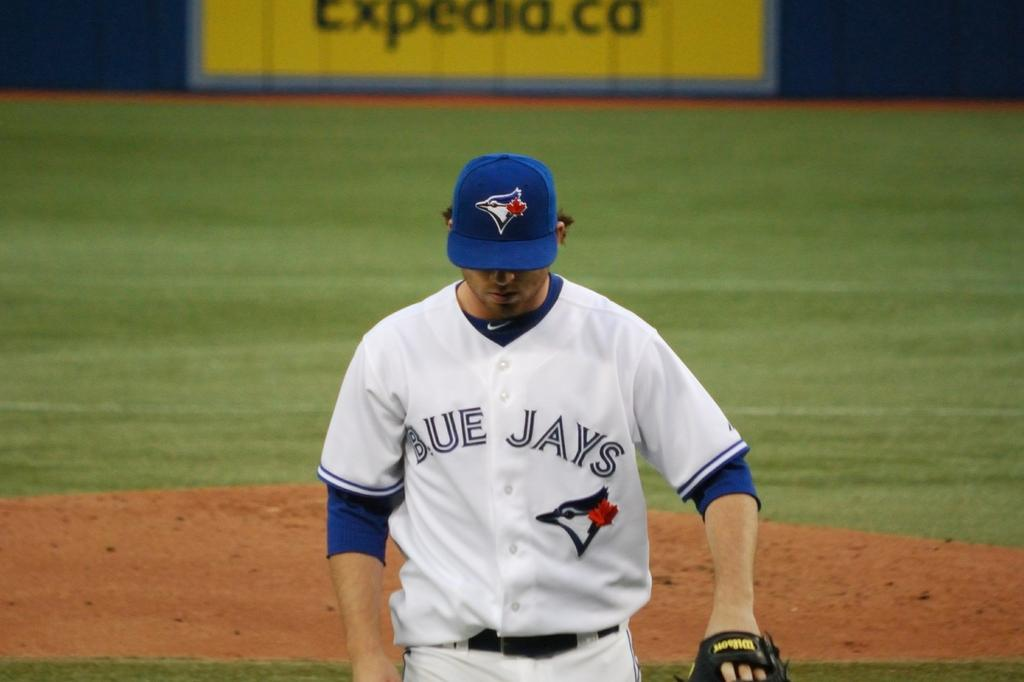<image>
Render a clear and concise summary of the photo. A professional baseball player for the Blue Jays deeply concentrating. 